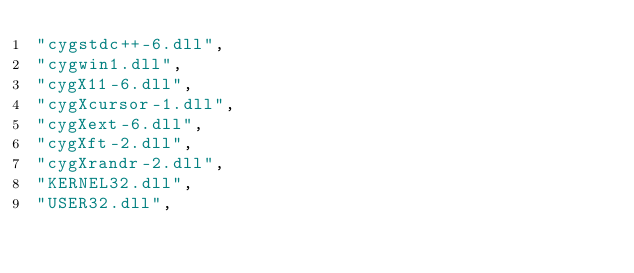Convert code to text. <code><loc_0><loc_0><loc_500><loc_500><_C++_>"cygstdc++-6.dll",
"cygwin1.dll",
"cygX11-6.dll",
"cygXcursor-1.dll",
"cygXext-6.dll",
"cygXft-2.dll",
"cygXrandr-2.dll",
"KERNEL32.dll",
"USER32.dll",
</code> 